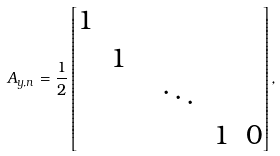<formula> <loc_0><loc_0><loc_500><loc_500>A _ { y , n } = \frac { 1 } { 2 } \left [ \begin{matrix} 1 & & \\ & 1 & \\ & & & \ddots & \\ & & & & 1 & 0 \end{matrix} \right ] ,</formula> 